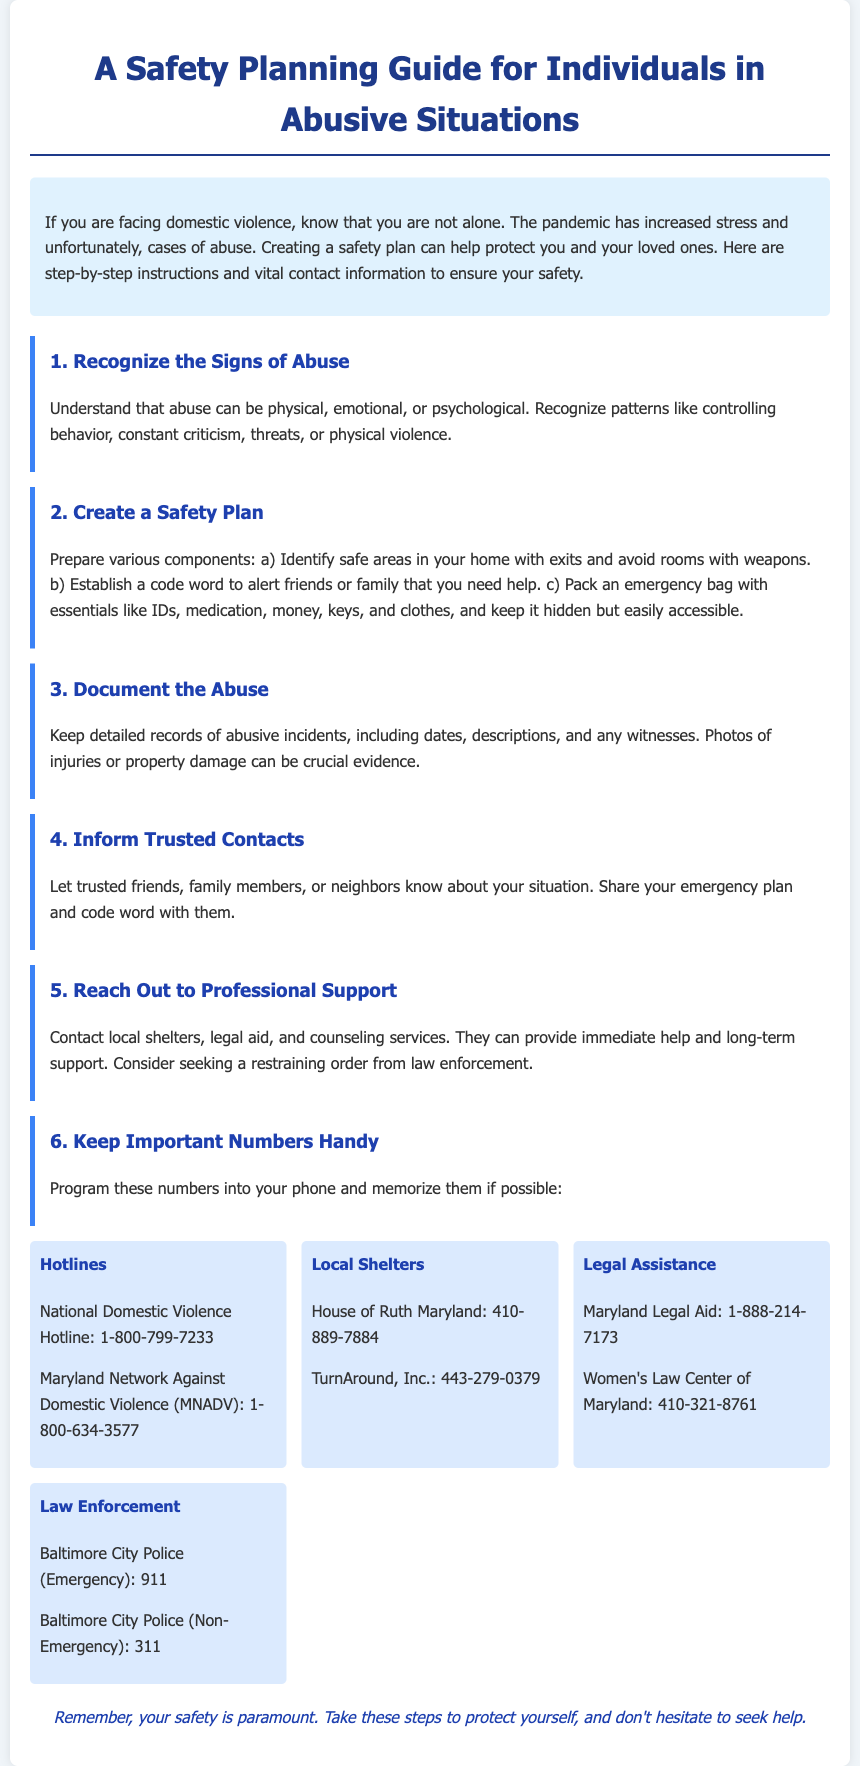What is the purpose of the guide? The guide's purpose is to help individuals facing domestic violence create a safety plan to protect themselves and their loved ones.
Answer: To help individuals facing domestic violence What is a safe area in your home? A safe area is a location where you can avoid potential confrontation and access exits without weapons present.
Answer: A location to avoid confrontation What items should be included in the emergency bag? The emergency bag should contain essentials like IDs, medication, money, keys, and clothes.
Answer: IDs, medication, money, keys, clothes What is the National Domestic Violence Hotline number? The hotline number is provided for immediate assistance and support for domestic violence victims.
Answer: 1-800-799-7233 Which organization can help with legal assistance? Legal assistance can be sought from Maryland Legal Aid and the Women's Law Center of Maryland.
Answer: Maryland Legal Aid, Women's Law Center What step involves keeping records of abusive incidents? Documenting the abuse involves keeping detailed accounts of incidents, including dates and descriptions.
Answer: Document the abuse What should you do if you need to alert someone that you need help? Establish a code word with friends or family to alert them in case of an emergency.
Answer: Establish a code word Which local shelter is mentioned in the guide? The guide mentions House of Ruth Maryland and TurnAround, Inc. as local shelter options.
Answer: House of Ruth Maryland, TurnAround, Inc 